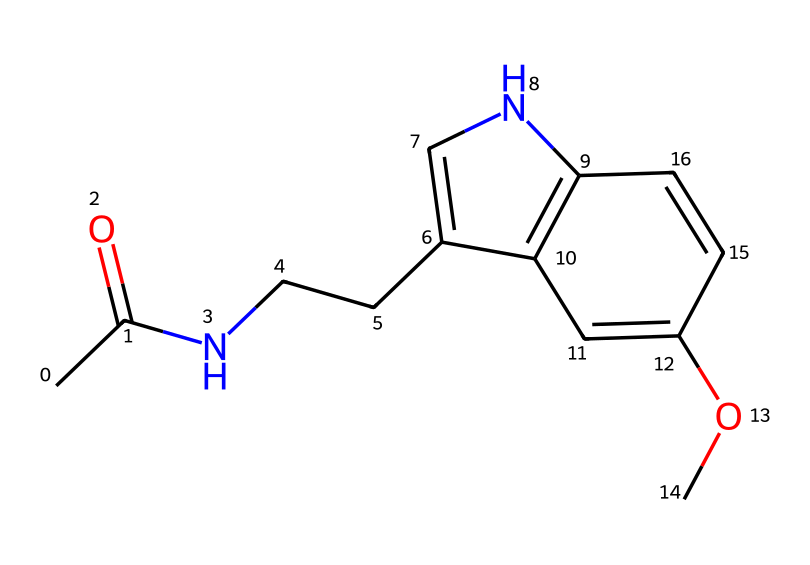What is the molecular formula of melatonin? By counting the atoms represented in the SMILES, we identify 13 carbon atoms, 16 hydrogen atoms, 2 nitrogen atoms, and 2 oxygen atoms. Therefore, the molecular formula is C13H16N2O2.
Answer: C13H16N2O2 How many rings are present in the structure? By examining the structure, we can identify two distinct cyclic components. One ring is a pyrrole-like structure and the other a benzene-like structure. This indicates there are two rings present.
Answer: 2 What type of functional groups are found in melatonin? In the structure represented by the SMILES, we can identify a carbonyl group (C=O) associated with the acetyl group and an amine group (–NH) in the molecule. Thus, the functional groups are amide and ether.
Answer: amide and ether What is the primary use of melatonin? Melatonin is widely known as a natural hormone that regulates sleep cycles, thus its primary use is as a sleep aid or supplement for promoting better sleep.
Answer: sleep aid What unique structural feature identifies melatonin as an imide? The imide is characterized by the presence of a nitrogen-containing ring structure bonded to a carbonyl group as seen in this molecule. The nitrogen atoms contribute to this classification, confirming its identity as an imide.
Answer: nitrogen-containing ring 